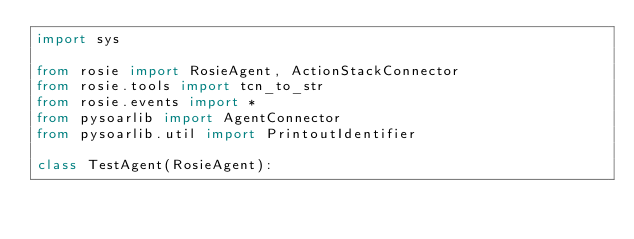<code> <loc_0><loc_0><loc_500><loc_500><_Python_>import sys

from rosie import RosieAgent, ActionStackConnector
from rosie.tools import tcn_to_str
from rosie.events import *
from pysoarlib import AgentConnector
from pysoarlib.util import PrintoutIdentifier

class TestAgent(RosieAgent):</code> 